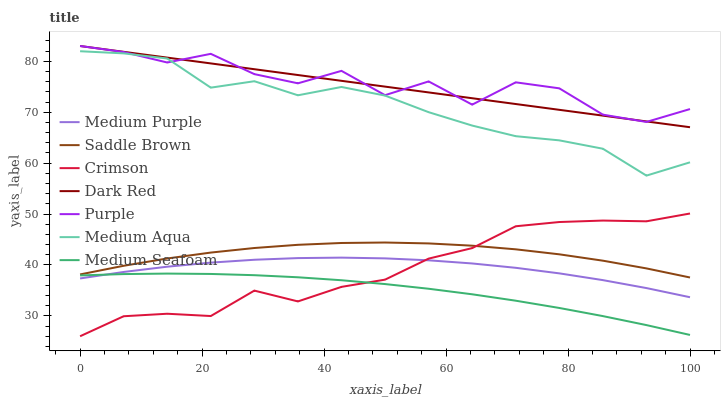Does Medium Seafoam have the minimum area under the curve?
Answer yes or no. Yes. Does Purple have the maximum area under the curve?
Answer yes or no. Yes. Does Dark Red have the minimum area under the curve?
Answer yes or no. No. Does Dark Red have the maximum area under the curve?
Answer yes or no. No. Is Dark Red the smoothest?
Answer yes or no. Yes. Is Purple the roughest?
Answer yes or no. Yes. Is Medium Seafoam the smoothest?
Answer yes or no. No. Is Medium Seafoam the roughest?
Answer yes or no. No. Does Crimson have the lowest value?
Answer yes or no. Yes. Does Dark Red have the lowest value?
Answer yes or no. No. Does Dark Red have the highest value?
Answer yes or no. Yes. Does Medium Seafoam have the highest value?
Answer yes or no. No. Is Medium Purple less than Dark Red?
Answer yes or no. Yes. Is Dark Red greater than Medium Aqua?
Answer yes or no. Yes. Does Medium Seafoam intersect Crimson?
Answer yes or no. Yes. Is Medium Seafoam less than Crimson?
Answer yes or no. No. Is Medium Seafoam greater than Crimson?
Answer yes or no. No. Does Medium Purple intersect Dark Red?
Answer yes or no. No. 